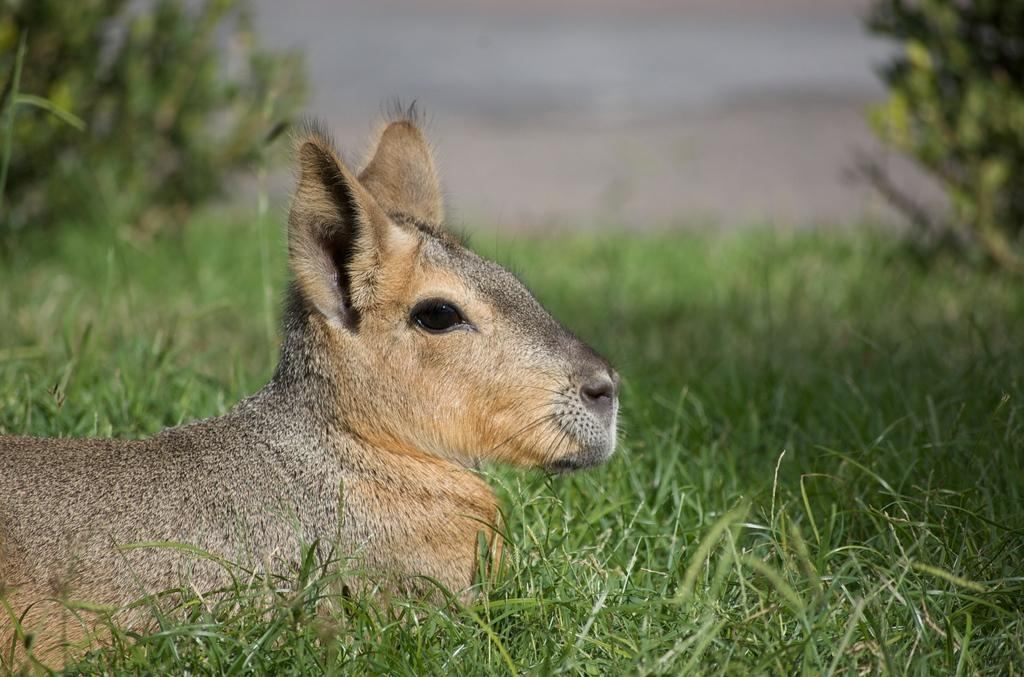What type of living creature is in the image? There is an animal in the image. Where is the animal located? The animal is on the grass. What other natural elements can be seen in the image? There are plants in the image. How would you describe the background of the image? The background of the image is blurred. How many light bulbs are hanging from the tree in the image? There are no light bulbs present in the image; it features an animal on the grass with plants and a blurred background. 